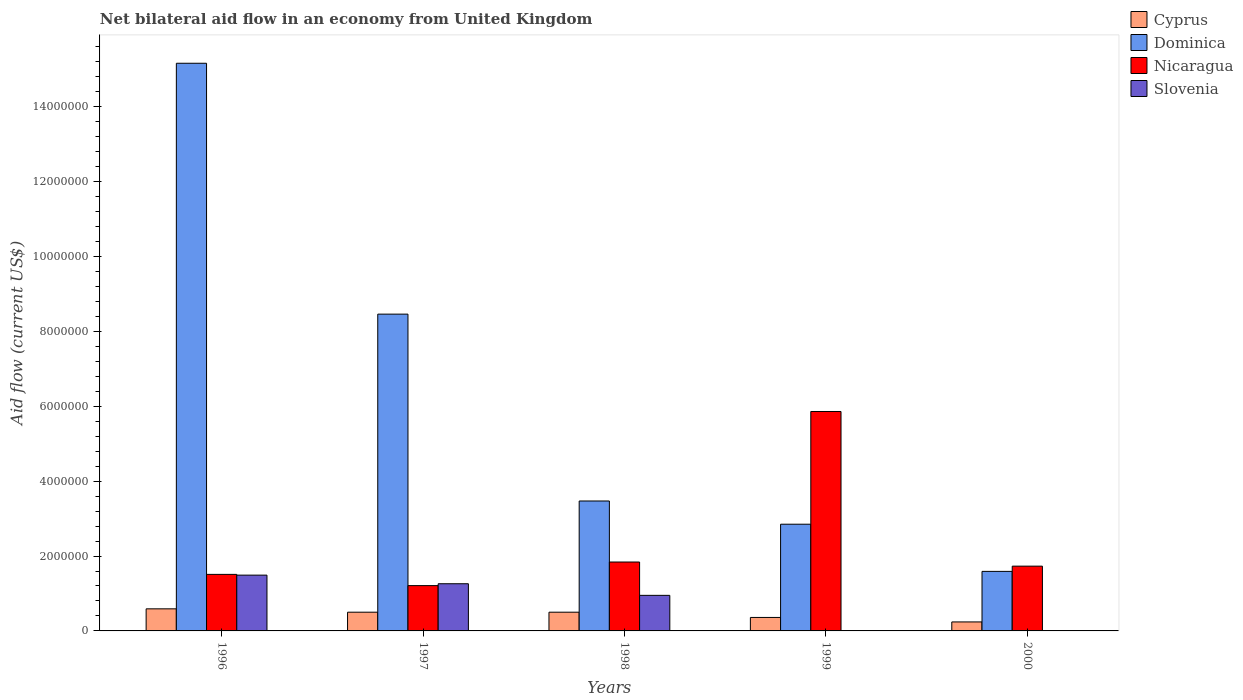In how many cases, is the number of bars for a given year not equal to the number of legend labels?
Offer a terse response. 2. What is the net bilateral aid flow in Cyprus in 1999?
Offer a very short reply. 3.60e+05. Across all years, what is the maximum net bilateral aid flow in Dominica?
Make the answer very short. 1.52e+07. What is the total net bilateral aid flow in Slovenia in the graph?
Offer a very short reply. 3.70e+06. What is the difference between the net bilateral aid flow in Dominica in 1998 and that in 2000?
Offer a very short reply. 1.88e+06. What is the difference between the net bilateral aid flow in Cyprus in 1997 and the net bilateral aid flow in Slovenia in 1996?
Provide a short and direct response. -9.90e+05. What is the average net bilateral aid flow in Nicaragua per year?
Make the answer very short. 2.43e+06. In the year 1997, what is the difference between the net bilateral aid flow in Dominica and net bilateral aid flow in Nicaragua?
Provide a short and direct response. 7.25e+06. In how many years, is the net bilateral aid flow in Dominica greater than 10400000 US$?
Your answer should be very brief. 1. What is the ratio of the net bilateral aid flow in Dominica in 1998 to that in 2000?
Provide a succinct answer. 2.18. Is the net bilateral aid flow in Nicaragua in 1997 less than that in 2000?
Offer a very short reply. Yes. What is the difference between the highest and the second highest net bilateral aid flow in Nicaragua?
Your answer should be compact. 4.02e+06. What is the difference between the highest and the lowest net bilateral aid flow in Dominica?
Give a very brief answer. 1.36e+07. In how many years, is the net bilateral aid flow in Nicaragua greater than the average net bilateral aid flow in Nicaragua taken over all years?
Offer a very short reply. 1. Is it the case that in every year, the sum of the net bilateral aid flow in Cyprus and net bilateral aid flow in Nicaragua is greater than the net bilateral aid flow in Dominica?
Your answer should be very brief. No. Are all the bars in the graph horizontal?
Offer a very short reply. No. Does the graph contain any zero values?
Offer a very short reply. Yes. Where does the legend appear in the graph?
Give a very brief answer. Top right. How many legend labels are there?
Provide a succinct answer. 4. How are the legend labels stacked?
Offer a very short reply. Vertical. What is the title of the graph?
Make the answer very short. Net bilateral aid flow in an economy from United Kingdom. What is the label or title of the X-axis?
Give a very brief answer. Years. What is the label or title of the Y-axis?
Offer a very short reply. Aid flow (current US$). What is the Aid flow (current US$) in Cyprus in 1996?
Provide a short and direct response. 5.90e+05. What is the Aid flow (current US$) in Dominica in 1996?
Give a very brief answer. 1.52e+07. What is the Aid flow (current US$) of Nicaragua in 1996?
Keep it short and to the point. 1.51e+06. What is the Aid flow (current US$) of Slovenia in 1996?
Ensure brevity in your answer.  1.49e+06. What is the Aid flow (current US$) of Cyprus in 1997?
Your answer should be very brief. 5.00e+05. What is the Aid flow (current US$) of Dominica in 1997?
Offer a very short reply. 8.46e+06. What is the Aid flow (current US$) in Nicaragua in 1997?
Provide a short and direct response. 1.21e+06. What is the Aid flow (current US$) in Slovenia in 1997?
Your answer should be compact. 1.26e+06. What is the Aid flow (current US$) in Cyprus in 1998?
Keep it short and to the point. 5.00e+05. What is the Aid flow (current US$) of Dominica in 1998?
Ensure brevity in your answer.  3.47e+06. What is the Aid flow (current US$) of Nicaragua in 1998?
Provide a succinct answer. 1.84e+06. What is the Aid flow (current US$) in Slovenia in 1998?
Give a very brief answer. 9.50e+05. What is the Aid flow (current US$) of Dominica in 1999?
Make the answer very short. 2.85e+06. What is the Aid flow (current US$) in Nicaragua in 1999?
Make the answer very short. 5.86e+06. What is the Aid flow (current US$) in Cyprus in 2000?
Provide a short and direct response. 2.40e+05. What is the Aid flow (current US$) in Dominica in 2000?
Offer a very short reply. 1.59e+06. What is the Aid flow (current US$) in Nicaragua in 2000?
Offer a terse response. 1.73e+06. What is the Aid flow (current US$) in Slovenia in 2000?
Provide a succinct answer. 0. Across all years, what is the maximum Aid flow (current US$) of Cyprus?
Offer a very short reply. 5.90e+05. Across all years, what is the maximum Aid flow (current US$) in Dominica?
Offer a very short reply. 1.52e+07. Across all years, what is the maximum Aid flow (current US$) of Nicaragua?
Your answer should be compact. 5.86e+06. Across all years, what is the maximum Aid flow (current US$) in Slovenia?
Offer a very short reply. 1.49e+06. Across all years, what is the minimum Aid flow (current US$) of Cyprus?
Keep it short and to the point. 2.40e+05. Across all years, what is the minimum Aid flow (current US$) of Dominica?
Your answer should be very brief. 1.59e+06. Across all years, what is the minimum Aid flow (current US$) in Nicaragua?
Provide a succinct answer. 1.21e+06. What is the total Aid flow (current US$) of Cyprus in the graph?
Keep it short and to the point. 2.19e+06. What is the total Aid flow (current US$) in Dominica in the graph?
Give a very brief answer. 3.15e+07. What is the total Aid flow (current US$) in Nicaragua in the graph?
Ensure brevity in your answer.  1.22e+07. What is the total Aid flow (current US$) of Slovenia in the graph?
Provide a short and direct response. 3.70e+06. What is the difference between the Aid flow (current US$) of Cyprus in 1996 and that in 1997?
Your answer should be compact. 9.00e+04. What is the difference between the Aid flow (current US$) of Dominica in 1996 and that in 1997?
Your answer should be compact. 6.70e+06. What is the difference between the Aid flow (current US$) in Dominica in 1996 and that in 1998?
Ensure brevity in your answer.  1.17e+07. What is the difference between the Aid flow (current US$) in Nicaragua in 1996 and that in 1998?
Your response must be concise. -3.30e+05. What is the difference between the Aid flow (current US$) in Slovenia in 1996 and that in 1998?
Provide a succinct answer. 5.40e+05. What is the difference between the Aid flow (current US$) of Cyprus in 1996 and that in 1999?
Make the answer very short. 2.30e+05. What is the difference between the Aid flow (current US$) in Dominica in 1996 and that in 1999?
Your answer should be compact. 1.23e+07. What is the difference between the Aid flow (current US$) of Nicaragua in 1996 and that in 1999?
Keep it short and to the point. -4.35e+06. What is the difference between the Aid flow (current US$) in Cyprus in 1996 and that in 2000?
Offer a very short reply. 3.50e+05. What is the difference between the Aid flow (current US$) in Dominica in 1996 and that in 2000?
Keep it short and to the point. 1.36e+07. What is the difference between the Aid flow (current US$) in Nicaragua in 1996 and that in 2000?
Offer a very short reply. -2.20e+05. What is the difference between the Aid flow (current US$) of Cyprus in 1997 and that in 1998?
Your answer should be compact. 0. What is the difference between the Aid flow (current US$) of Dominica in 1997 and that in 1998?
Your response must be concise. 4.99e+06. What is the difference between the Aid flow (current US$) of Nicaragua in 1997 and that in 1998?
Keep it short and to the point. -6.30e+05. What is the difference between the Aid flow (current US$) of Cyprus in 1997 and that in 1999?
Your answer should be very brief. 1.40e+05. What is the difference between the Aid flow (current US$) in Dominica in 1997 and that in 1999?
Provide a succinct answer. 5.61e+06. What is the difference between the Aid flow (current US$) in Nicaragua in 1997 and that in 1999?
Your answer should be compact. -4.65e+06. What is the difference between the Aid flow (current US$) of Cyprus in 1997 and that in 2000?
Offer a terse response. 2.60e+05. What is the difference between the Aid flow (current US$) of Dominica in 1997 and that in 2000?
Provide a succinct answer. 6.87e+06. What is the difference between the Aid flow (current US$) in Nicaragua in 1997 and that in 2000?
Offer a terse response. -5.20e+05. What is the difference between the Aid flow (current US$) in Cyprus in 1998 and that in 1999?
Ensure brevity in your answer.  1.40e+05. What is the difference between the Aid flow (current US$) in Dominica in 1998 and that in 1999?
Keep it short and to the point. 6.20e+05. What is the difference between the Aid flow (current US$) of Nicaragua in 1998 and that in 1999?
Make the answer very short. -4.02e+06. What is the difference between the Aid flow (current US$) in Dominica in 1998 and that in 2000?
Provide a short and direct response. 1.88e+06. What is the difference between the Aid flow (current US$) in Nicaragua in 1998 and that in 2000?
Provide a succinct answer. 1.10e+05. What is the difference between the Aid flow (current US$) of Cyprus in 1999 and that in 2000?
Offer a terse response. 1.20e+05. What is the difference between the Aid flow (current US$) in Dominica in 1999 and that in 2000?
Offer a very short reply. 1.26e+06. What is the difference between the Aid flow (current US$) in Nicaragua in 1999 and that in 2000?
Ensure brevity in your answer.  4.13e+06. What is the difference between the Aid flow (current US$) of Cyprus in 1996 and the Aid flow (current US$) of Dominica in 1997?
Make the answer very short. -7.87e+06. What is the difference between the Aid flow (current US$) in Cyprus in 1996 and the Aid flow (current US$) in Nicaragua in 1997?
Your answer should be compact. -6.20e+05. What is the difference between the Aid flow (current US$) of Cyprus in 1996 and the Aid flow (current US$) of Slovenia in 1997?
Your answer should be compact. -6.70e+05. What is the difference between the Aid flow (current US$) of Dominica in 1996 and the Aid flow (current US$) of Nicaragua in 1997?
Offer a very short reply. 1.40e+07. What is the difference between the Aid flow (current US$) of Dominica in 1996 and the Aid flow (current US$) of Slovenia in 1997?
Give a very brief answer. 1.39e+07. What is the difference between the Aid flow (current US$) of Cyprus in 1996 and the Aid flow (current US$) of Dominica in 1998?
Your response must be concise. -2.88e+06. What is the difference between the Aid flow (current US$) of Cyprus in 1996 and the Aid flow (current US$) of Nicaragua in 1998?
Ensure brevity in your answer.  -1.25e+06. What is the difference between the Aid flow (current US$) in Cyprus in 1996 and the Aid flow (current US$) in Slovenia in 1998?
Your response must be concise. -3.60e+05. What is the difference between the Aid flow (current US$) of Dominica in 1996 and the Aid flow (current US$) of Nicaragua in 1998?
Provide a short and direct response. 1.33e+07. What is the difference between the Aid flow (current US$) in Dominica in 1996 and the Aid flow (current US$) in Slovenia in 1998?
Ensure brevity in your answer.  1.42e+07. What is the difference between the Aid flow (current US$) of Nicaragua in 1996 and the Aid flow (current US$) of Slovenia in 1998?
Provide a short and direct response. 5.60e+05. What is the difference between the Aid flow (current US$) in Cyprus in 1996 and the Aid flow (current US$) in Dominica in 1999?
Keep it short and to the point. -2.26e+06. What is the difference between the Aid flow (current US$) of Cyprus in 1996 and the Aid flow (current US$) of Nicaragua in 1999?
Ensure brevity in your answer.  -5.27e+06. What is the difference between the Aid flow (current US$) of Dominica in 1996 and the Aid flow (current US$) of Nicaragua in 1999?
Keep it short and to the point. 9.30e+06. What is the difference between the Aid flow (current US$) in Cyprus in 1996 and the Aid flow (current US$) in Nicaragua in 2000?
Your answer should be very brief. -1.14e+06. What is the difference between the Aid flow (current US$) in Dominica in 1996 and the Aid flow (current US$) in Nicaragua in 2000?
Give a very brief answer. 1.34e+07. What is the difference between the Aid flow (current US$) in Cyprus in 1997 and the Aid flow (current US$) in Dominica in 1998?
Ensure brevity in your answer.  -2.97e+06. What is the difference between the Aid flow (current US$) of Cyprus in 1997 and the Aid flow (current US$) of Nicaragua in 1998?
Your answer should be compact. -1.34e+06. What is the difference between the Aid flow (current US$) in Cyprus in 1997 and the Aid flow (current US$) in Slovenia in 1998?
Give a very brief answer. -4.50e+05. What is the difference between the Aid flow (current US$) of Dominica in 1997 and the Aid flow (current US$) of Nicaragua in 1998?
Your answer should be very brief. 6.62e+06. What is the difference between the Aid flow (current US$) of Dominica in 1997 and the Aid flow (current US$) of Slovenia in 1998?
Your answer should be very brief. 7.51e+06. What is the difference between the Aid flow (current US$) in Nicaragua in 1997 and the Aid flow (current US$) in Slovenia in 1998?
Keep it short and to the point. 2.60e+05. What is the difference between the Aid flow (current US$) of Cyprus in 1997 and the Aid flow (current US$) of Dominica in 1999?
Give a very brief answer. -2.35e+06. What is the difference between the Aid flow (current US$) in Cyprus in 1997 and the Aid flow (current US$) in Nicaragua in 1999?
Offer a very short reply. -5.36e+06. What is the difference between the Aid flow (current US$) of Dominica in 1997 and the Aid flow (current US$) of Nicaragua in 1999?
Offer a very short reply. 2.60e+06. What is the difference between the Aid flow (current US$) of Cyprus in 1997 and the Aid flow (current US$) of Dominica in 2000?
Your answer should be compact. -1.09e+06. What is the difference between the Aid flow (current US$) in Cyprus in 1997 and the Aid flow (current US$) in Nicaragua in 2000?
Your answer should be very brief. -1.23e+06. What is the difference between the Aid flow (current US$) in Dominica in 1997 and the Aid flow (current US$) in Nicaragua in 2000?
Offer a terse response. 6.73e+06. What is the difference between the Aid flow (current US$) in Cyprus in 1998 and the Aid flow (current US$) in Dominica in 1999?
Give a very brief answer. -2.35e+06. What is the difference between the Aid flow (current US$) in Cyprus in 1998 and the Aid flow (current US$) in Nicaragua in 1999?
Offer a very short reply. -5.36e+06. What is the difference between the Aid flow (current US$) of Dominica in 1998 and the Aid flow (current US$) of Nicaragua in 1999?
Your answer should be compact. -2.39e+06. What is the difference between the Aid flow (current US$) of Cyprus in 1998 and the Aid flow (current US$) of Dominica in 2000?
Offer a terse response. -1.09e+06. What is the difference between the Aid flow (current US$) of Cyprus in 1998 and the Aid flow (current US$) of Nicaragua in 2000?
Offer a very short reply. -1.23e+06. What is the difference between the Aid flow (current US$) of Dominica in 1998 and the Aid flow (current US$) of Nicaragua in 2000?
Your answer should be very brief. 1.74e+06. What is the difference between the Aid flow (current US$) in Cyprus in 1999 and the Aid flow (current US$) in Dominica in 2000?
Your response must be concise. -1.23e+06. What is the difference between the Aid flow (current US$) in Cyprus in 1999 and the Aid flow (current US$) in Nicaragua in 2000?
Your answer should be compact. -1.37e+06. What is the difference between the Aid flow (current US$) in Dominica in 1999 and the Aid flow (current US$) in Nicaragua in 2000?
Ensure brevity in your answer.  1.12e+06. What is the average Aid flow (current US$) of Cyprus per year?
Make the answer very short. 4.38e+05. What is the average Aid flow (current US$) of Dominica per year?
Your answer should be very brief. 6.31e+06. What is the average Aid flow (current US$) of Nicaragua per year?
Give a very brief answer. 2.43e+06. What is the average Aid flow (current US$) of Slovenia per year?
Make the answer very short. 7.40e+05. In the year 1996, what is the difference between the Aid flow (current US$) of Cyprus and Aid flow (current US$) of Dominica?
Give a very brief answer. -1.46e+07. In the year 1996, what is the difference between the Aid flow (current US$) in Cyprus and Aid flow (current US$) in Nicaragua?
Offer a terse response. -9.20e+05. In the year 1996, what is the difference between the Aid flow (current US$) of Cyprus and Aid flow (current US$) of Slovenia?
Provide a short and direct response. -9.00e+05. In the year 1996, what is the difference between the Aid flow (current US$) of Dominica and Aid flow (current US$) of Nicaragua?
Provide a succinct answer. 1.36e+07. In the year 1996, what is the difference between the Aid flow (current US$) of Dominica and Aid flow (current US$) of Slovenia?
Your answer should be compact. 1.37e+07. In the year 1996, what is the difference between the Aid flow (current US$) in Nicaragua and Aid flow (current US$) in Slovenia?
Provide a succinct answer. 2.00e+04. In the year 1997, what is the difference between the Aid flow (current US$) in Cyprus and Aid flow (current US$) in Dominica?
Your response must be concise. -7.96e+06. In the year 1997, what is the difference between the Aid flow (current US$) in Cyprus and Aid flow (current US$) in Nicaragua?
Make the answer very short. -7.10e+05. In the year 1997, what is the difference between the Aid flow (current US$) in Cyprus and Aid flow (current US$) in Slovenia?
Give a very brief answer. -7.60e+05. In the year 1997, what is the difference between the Aid flow (current US$) in Dominica and Aid flow (current US$) in Nicaragua?
Ensure brevity in your answer.  7.25e+06. In the year 1997, what is the difference between the Aid flow (current US$) of Dominica and Aid flow (current US$) of Slovenia?
Your answer should be very brief. 7.20e+06. In the year 1997, what is the difference between the Aid flow (current US$) of Nicaragua and Aid flow (current US$) of Slovenia?
Keep it short and to the point. -5.00e+04. In the year 1998, what is the difference between the Aid flow (current US$) of Cyprus and Aid flow (current US$) of Dominica?
Offer a very short reply. -2.97e+06. In the year 1998, what is the difference between the Aid flow (current US$) of Cyprus and Aid flow (current US$) of Nicaragua?
Your response must be concise. -1.34e+06. In the year 1998, what is the difference between the Aid flow (current US$) of Cyprus and Aid flow (current US$) of Slovenia?
Your answer should be very brief. -4.50e+05. In the year 1998, what is the difference between the Aid flow (current US$) of Dominica and Aid flow (current US$) of Nicaragua?
Make the answer very short. 1.63e+06. In the year 1998, what is the difference between the Aid flow (current US$) in Dominica and Aid flow (current US$) in Slovenia?
Provide a succinct answer. 2.52e+06. In the year 1998, what is the difference between the Aid flow (current US$) in Nicaragua and Aid flow (current US$) in Slovenia?
Make the answer very short. 8.90e+05. In the year 1999, what is the difference between the Aid flow (current US$) of Cyprus and Aid flow (current US$) of Dominica?
Your response must be concise. -2.49e+06. In the year 1999, what is the difference between the Aid flow (current US$) of Cyprus and Aid flow (current US$) of Nicaragua?
Offer a very short reply. -5.50e+06. In the year 1999, what is the difference between the Aid flow (current US$) of Dominica and Aid flow (current US$) of Nicaragua?
Ensure brevity in your answer.  -3.01e+06. In the year 2000, what is the difference between the Aid flow (current US$) in Cyprus and Aid flow (current US$) in Dominica?
Offer a very short reply. -1.35e+06. In the year 2000, what is the difference between the Aid flow (current US$) of Cyprus and Aid flow (current US$) of Nicaragua?
Your answer should be very brief. -1.49e+06. In the year 2000, what is the difference between the Aid flow (current US$) of Dominica and Aid flow (current US$) of Nicaragua?
Keep it short and to the point. -1.40e+05. What is the ratio of the Aid flow (current US$) in Cyprus in 1996 to that in 1997?
Keep it short and to the point. 1.18. What is the ratio of the Aid flow (current US$) in Dominica in 1996 to that in 1997?
Your answer should be compact. 1.79. What is the ratio of the Aid flow (current US$) in Nicaragua in 1996 to that in 1997?
Keep it short and to the point. 1.25. What is the ratio of the Aid flow (current US$) in Slovenia in 1996 to that in 1997?
Keep it short and to the point. 1.18. What is the ratio of the Aid flow (current US$) of Cyprus in 1996 to that in 1998?
Your response must be concise. 1.18. What is the ratio of the Aid flow (current US$) of Dominica in 1996 to that in 1998?
Your answer should be compact. 4.37. What is the ratio of the Aid flow (current US$) of Nicaragua in 1996 to that in 1998?
Offer a very short reply. 0.82. What is the ratio of the Aid flow (current US$) in Slovenia in 1996 to that in 1998?
Provide a succinct answer. 1.57. What is the ratio of the Aid flow (current US$) in Cyprus in 1996 to that in 1999?
Offer a very short reply. 1.64. What is the ratio of the Aid flow (current US$) in Dominica in 1996 to that in 1999?
Make the answer very short. 5.32. What is the ratio of the Aid flow (current US$) in Nicaragua in 1996 to that in 1999?
Your answer should be very brief. 0.26. What is the ratio of the Aid flow (current US$) in Cyprus in 1996 to that in 2000?
Your answer should be very brief. 2.46. What is the ratio of the Aid flow (current US$) of Dominica in 1996 to that in 2000?
Provide a short and direct response. 9.53. What is the ratio of the Aid flow (current US$) of Nicaragua in 1996 to that in 2000?
Your response must be concise. 0.87. What is the ratio of the Aid flow (current US$) of Dominica in 1997 to that in 1998?
Offer a terse response. 2.44. What is the ratio of the Aid flow (current US$) in Nicaragua in 1997 to that in 1998?
Ensure brevity in your answer.  0.66. What is the ratio of the Aid flow (current US$) in Slovenia in 1997 to that in 1998?
Your response must be concise. 1.33. What is the ratio of the Aid flow (current US$) in Cyprus in 1997 to that in 1999?
Your answer should be compact. 1.39. What is the ratio of the Aid flow (current US$) in Dominica in 1997 to that in 1999?
Keep it short and to the point. 2.97. What is the ratio of the Aid flow (current US$) in Nicaragua in 1997 to that in 1999?
Offer a terse response. 0.21. What is the ratio of the Aid flow (current US$) of Cyprus in 1997 to that in 2000?
Offer a terse response. 2.08. What is the ratio of the Aid flow (current US$) of Dominica in 1997 to that in 2000?
Your answer should be compact. 5.32. What is the ratio of the Aid flow (current US$) in Nicaragua in 1997 to that in 2000?
Offer a very short reply. 0.7. What is the ratio of the Aid flow (current US$) of Cyprus in 1998 to that in 1999?
Your answer should be very brief. 1.39. What is the ratio of the Aid flow (current US$) of Dominica in 1998 to that in 1999?
Offer a terse response. 1.22. What is the ratio of the Aid flow (current US$) in Nicaragua in 1998 to that in 1999?
Your response must be concise. 0.31. What is the ratio of the Aid flow (current US$) of Cyprus in 1998 to that in 2000?
Make the answer very short. 2.08. What is the ratio of the Aid flow (current US$) in Dominica in 1998 to that in 2000?
Your answer should be very brief. 2.18. What is the ratio of the Aid flow (current US$) of Nicaragua in 1998 to that in 2000?
Offer a terse response. 1.06. What is the ratio of the Aid flow (current US$) of Cyprus in 1999 to that in 2000?
Offer a very short reply. 1.5. What is the ratio of the Aid flow (current US$) of Dominica in 1999 to that in 2000?
Provide a short and direct response. 1.79. What is the ratio of the Aid flow (current US$) of Nicaragua in 1999 to that in 2000?
Make the answer very short. 3.39. What is the difference between the highest and the second highest Aid flow (current US$) in Dominica?
Provide a succinct answer. 6.70e+06. What is the difference between the highest and the second highest Aid flow (current US$) of Nicaragua?
Offer a very short reply. 4.02e+06. What is the difference between the highest and the lowest Aid flow (current US$) of Dominica?
Your response must be concise. 1.36e+07. What is the difference between the highest and the lowest Aid flow (current US$) in Nicaragua?
Give a very brief answer. 4.65e+06. What is the difference between the highest and the lowest Aid flow (current US$) of Slovenia?
Make the answer very short. 1.49e+06. 